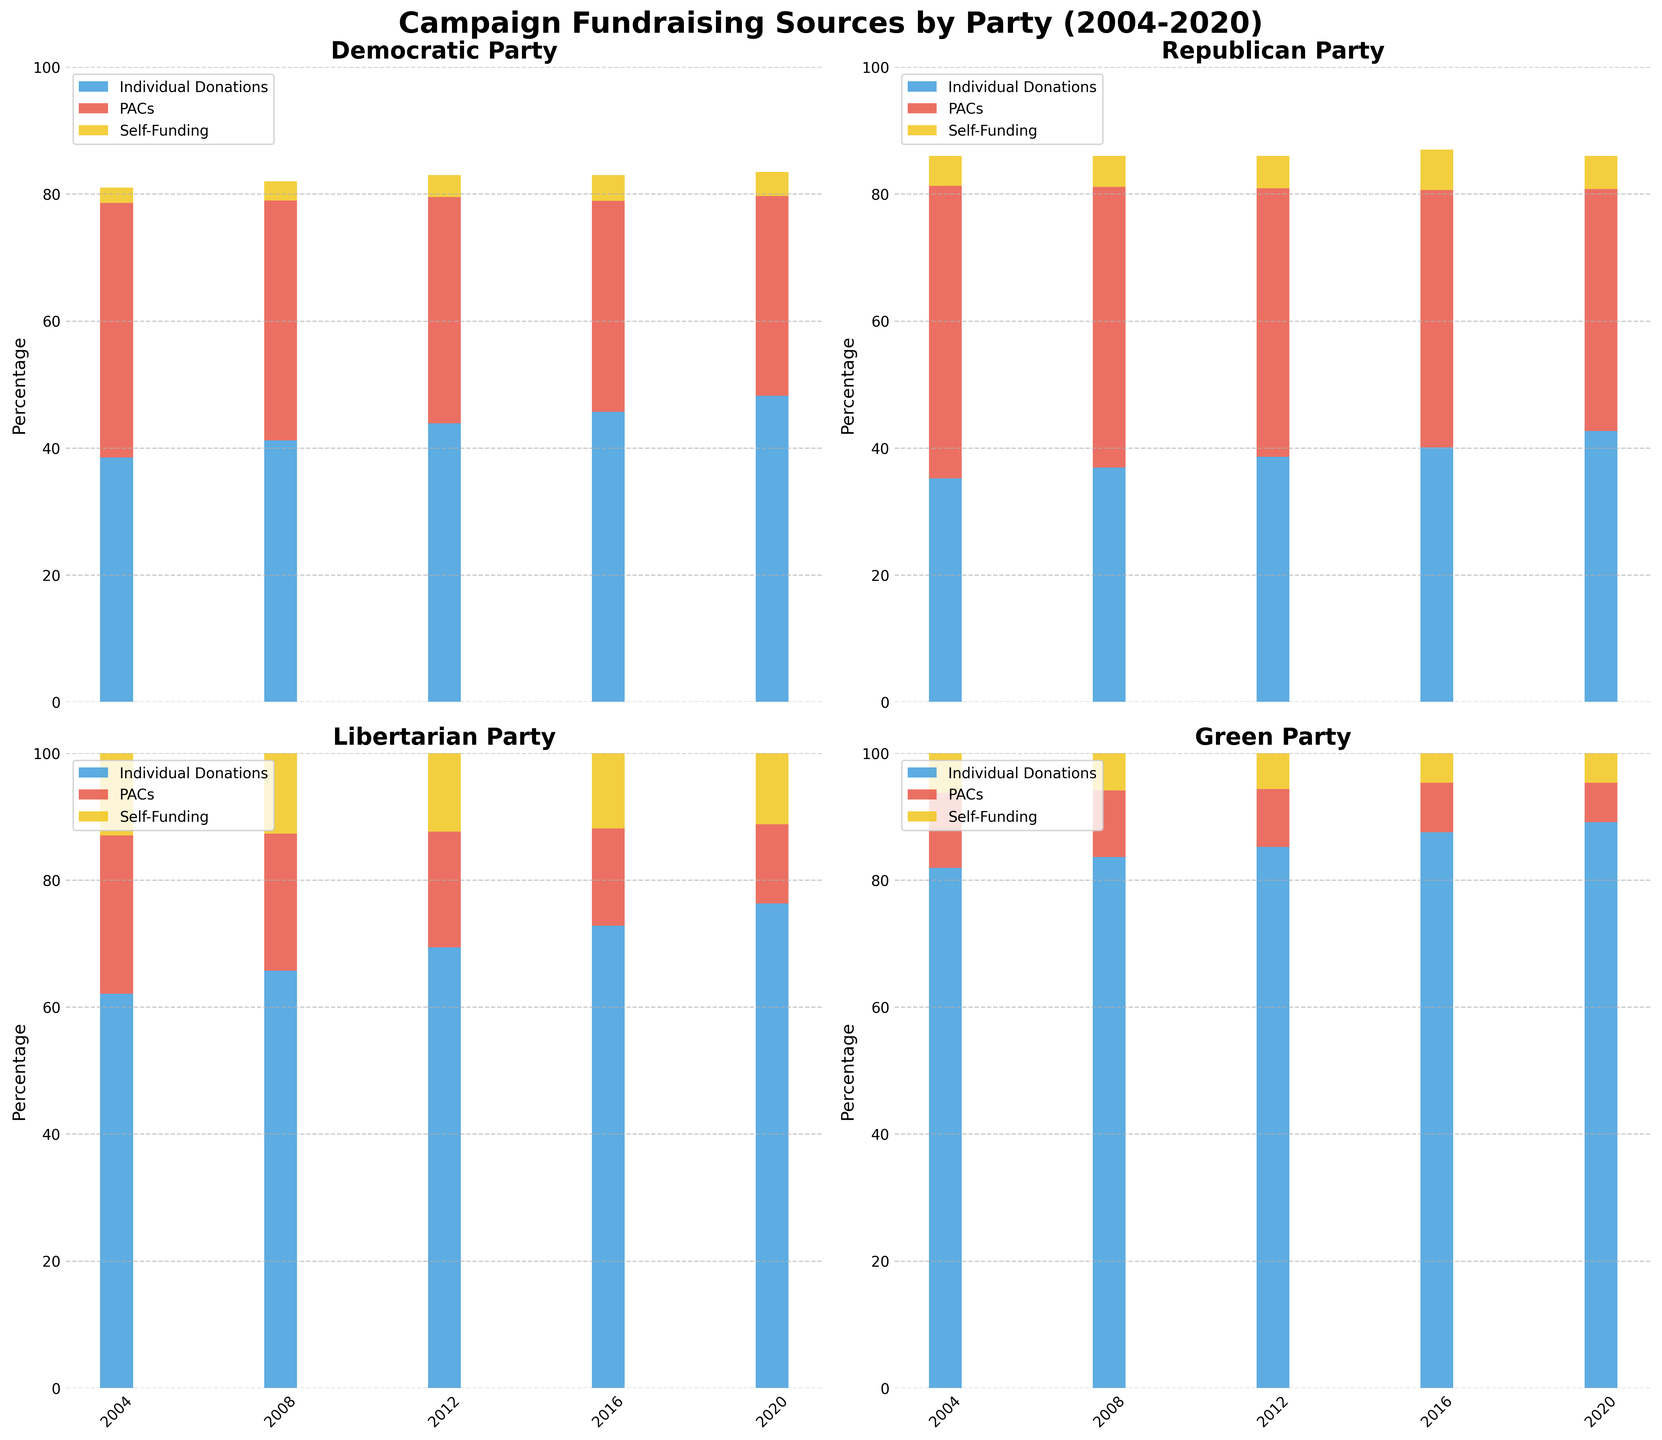What percentage of the Republican Party's funding came from individual donations in the 2020 election cycle? Look at the Republican Party section in the plot for the 2020 cycle, read the height of "Individual Donations" bar.
Answer: 42.7% Which party had the highest percentage of PAC donations in the 2012 election cycle? Compare the heights of the "PAC" bars across all parties for the 2012 election cycle.
Answer: Republican Party What is the difference between the percentage of individual donations for the Green Party in 2004 and 2020? Subtract the height of the "Individual Donations" bar of the Green Party in 2004 from that in 2020.
Answer: 7.2% How did the percentage of self-funding change for the Democratic Party from 2004 to 2020? Observe the difference in heights of the "Self-Funding" bars for the Democratic Party between 2004 and 2020.
Answer: Increased by 1.4% Which election cycle had the highest total percentage of funds from PACs for the Libertarian Party? Compare the heights of the "PAC" bars for each cycle in the Libertarian Party section.
Answer: 2004 Which party and election cycle combination had the lowest percentage of self-funding, and what was it? Look for the shortest "Self-Funding" bar across all parties and election cycles.
Answer: Democratic Party, 2008, 3.0% What is the average percentage of individual donations for the Green Party over all election cycles? Sum the heights of the "Individual Donations" bars for the Green Party over all cycles and then divide by the number of cycles (5).
Answer: 85.46% Compare the trends of PAC donations for the Democratic and Republican Parties from 2004 to 2020. Observe the general direction (increase, decrease, or steady) of the "PAC" bars' heights in each election cycle for both parties.
Answer: Democratic Party: Decreasing; Republican Party: Decreasing then Increasing By how much did the Republican Party's individual donations increase from 2004 to 2020? Subtract the value of the "Individual Donations" bar in 2004 from the value in 2020 for the Republican Party.
Answer: 7.5% 